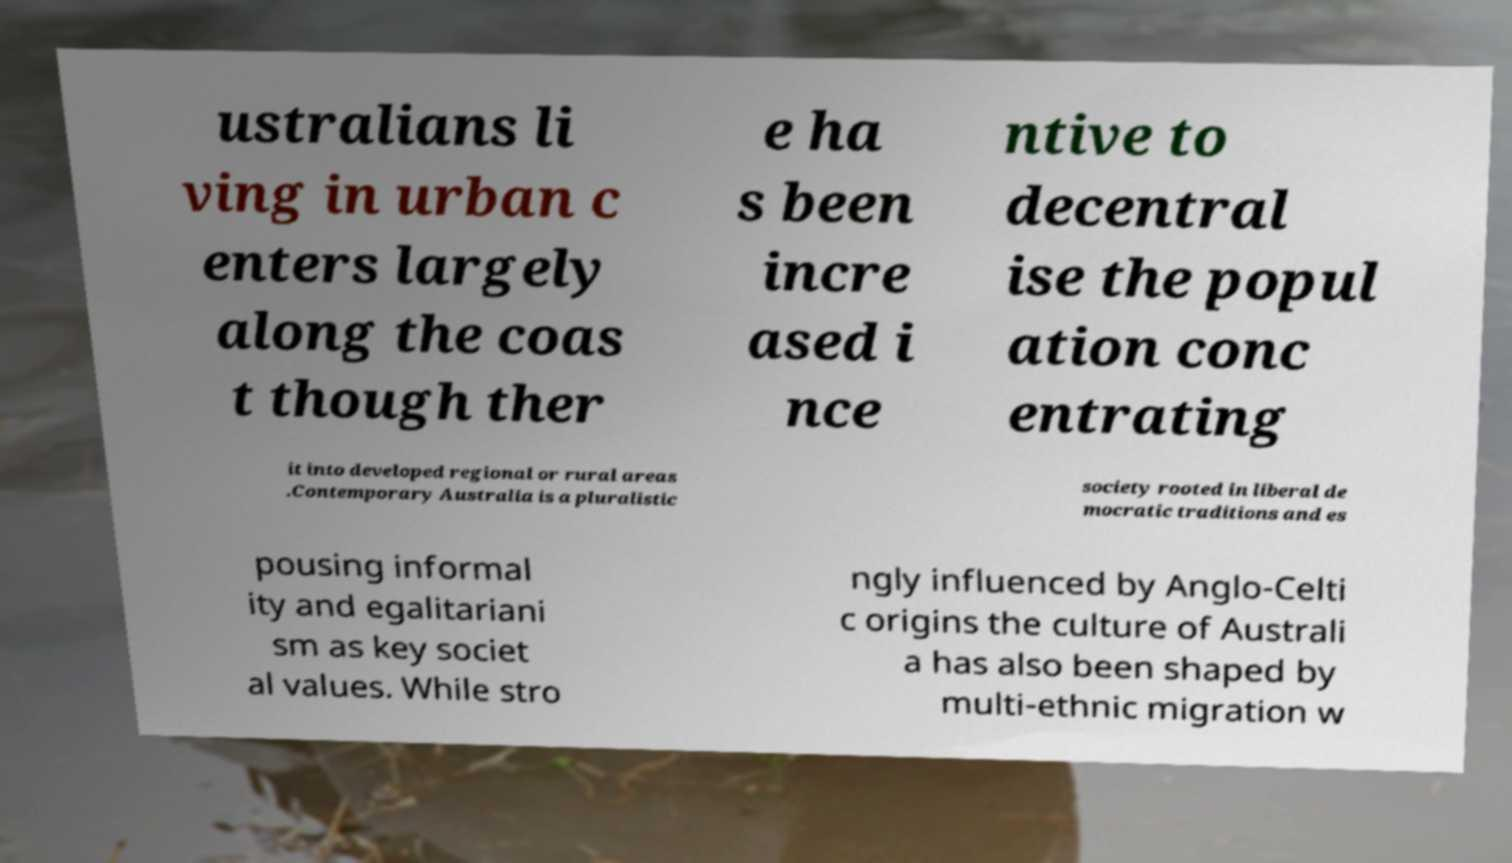What messages or text are displayed in this image? I need them in a readable, typed format. ustralians li ving in urban c enters largely along the coas t though ther e ha s been incre ased i nce ntive to decentral ise the popul ation conc entrating it into developed regional or rural areas .Contemporary Australia is a pluralistic society rooted in liberal de mocratic traditions and es pousing informal ity and egalitariani sm as key societ al values. While stro ngly influenced by Anglo-Celti c origins the culture of Australi a has also been shaped by multi-ethnic migration w 